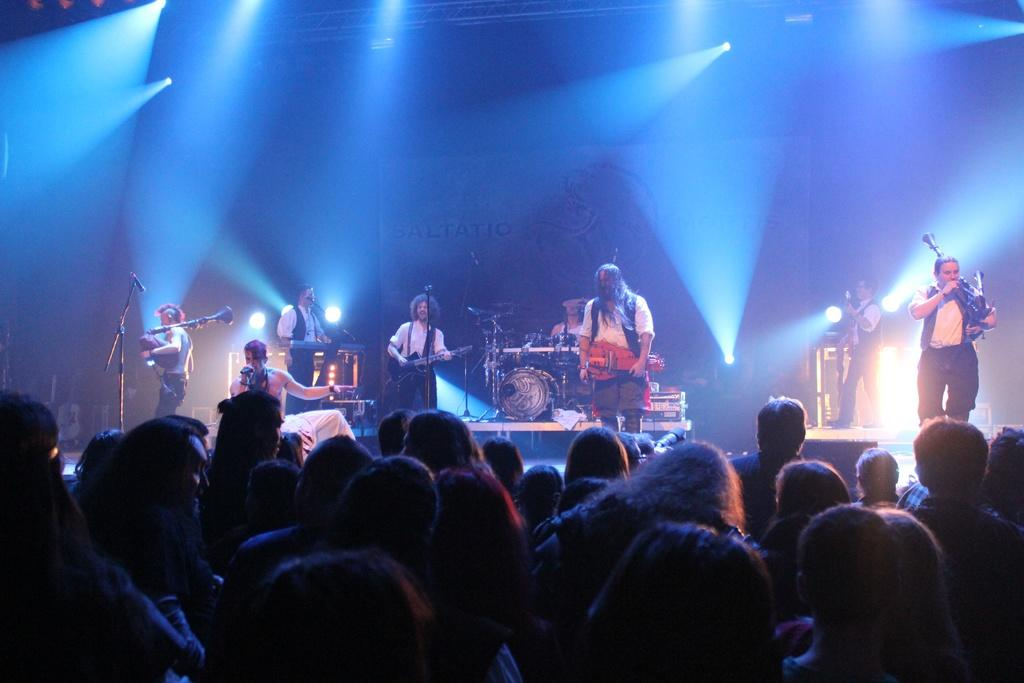What are the people in the image doing? There is a group of people playing musical instruments in the image. Are there any other people in the image? Yes, there is a group of people watching the performance in the image. What type of smoke can be seen coming from the instruments in the image? There is no smoke coming from the instruments in the image; they are not on fire or producing any smoke. 